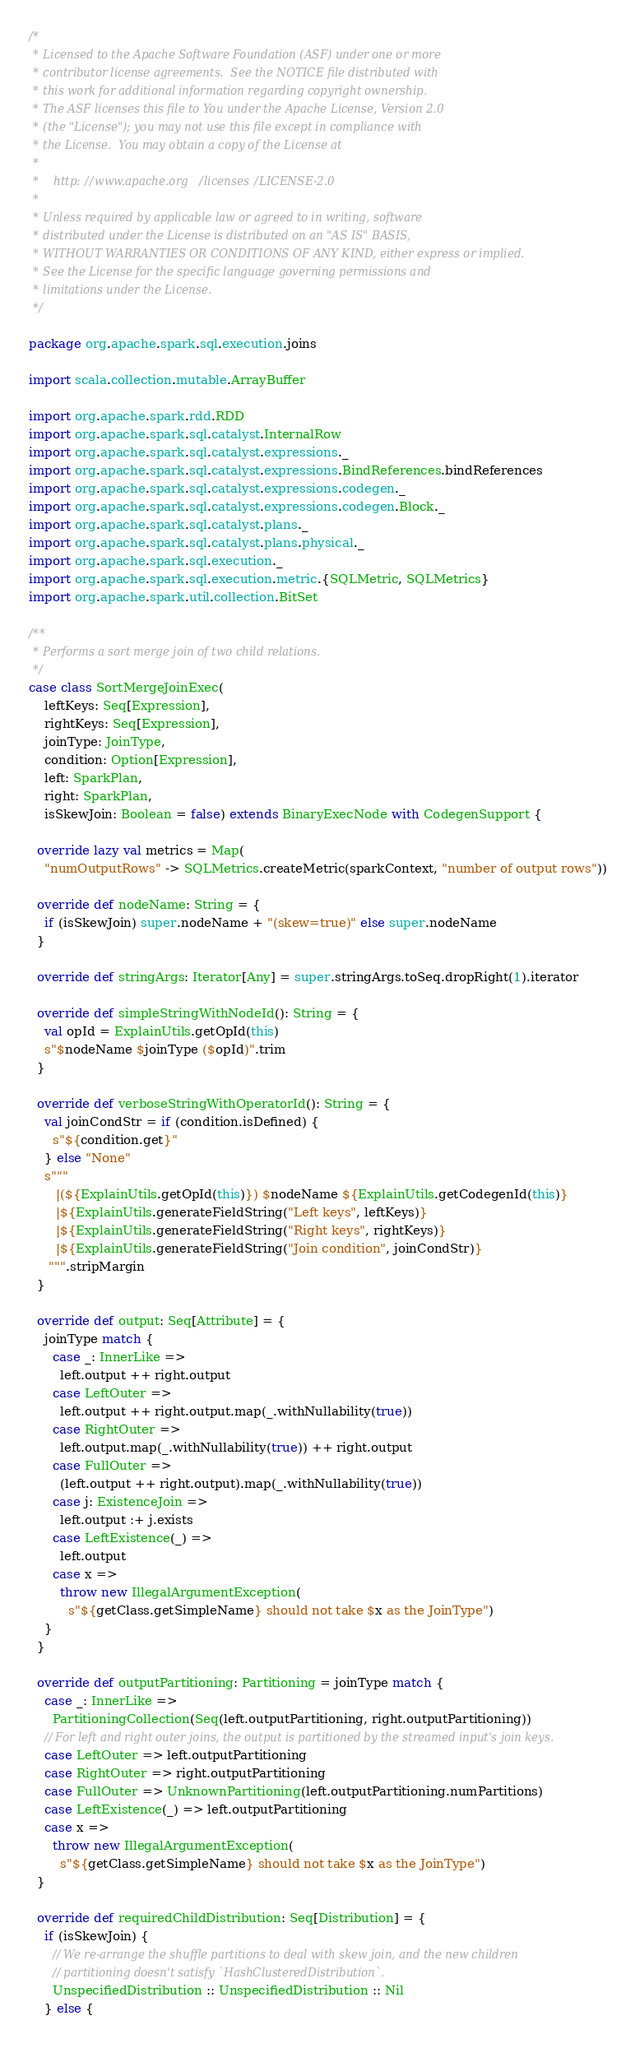<code> <loc_0><loc_0><loc_500><loc_500><_Scala_>/*
 * Licensed to the Apache Software Foundation (ASF) under one or more
 * contributor license agreements.  See the NOTICE file distributed with
 * this work for additional information regarding copyright ownership.
 * The ASF licenses this file to You under the Apache License, Version 2.0
 * (the "License"); you may not use this file except in compliance with
 * the License.  You may obtain a copy of the License at
 *
 *    http://www.apache.org/licenses/LICENSE-2.0
 *
 * Unless required by applicable law or agreed to in writing, software
 * distributed under the License is distributed on an "AS IS" BASIS,
 * WITHOUT WARRANTIES OR CONDITIONS OF ANY KIND, either express or implied.
 * See the License for the specific language governing permissions and
 * limitations under the License.
 */

package org.apache.spark.sql.execution.joins

import scala.collection.mutable.ArrayBuffer

import org.apache.spark.rdd.RDD
import org.apache.spark.sql.catalyst.InternalRow
import org.apache.spark.sql.catalyst.expressions._
import org.apache.spark.sql.catalyst.expressions.BindReferences.bindReferences
import org.apache.spark.sql.catalyst.expressions.codegen._
import org.apache.spark.sql.catalyst.expressions.codegen.Block._
import org.apache.spark.sql.catalyst.plans._
import org.apache.spark.sql.catalyst.plans.physical._
import org.apache.spark.sql.execution._
import org.apache.spark.sql.execution.metric.{SQLMetric, SQLMetrics}
import org.apache.spark.util.collection.BitSet

/**
 * Performs a sort merge join of two child relations.
 */
case class SortMergeJoinExec(
    leftKeys: Seq[Expression],
    rightKeys: Seq[Expression],
    joinType: JoinType,
    condition: Option[Expression],
    left: SparkPlan,
    right: SparkPlan,
    isSkewJoin: Boolean = false) extends BinaryExecNode with CodegenSupport {

  override lazy val metrics = Map(
    "numOutputRows" -> SQLMetrics.createMetric(sparkContext, "number of output rows"))

  override def nodeName: String = {
    if (isSkewJoin) super.nodeName + "(skew=true)" else super.nodeName
  }

  override def stringArgs: Iterator[Any] = super.stringArgs.toSeq.dropRight(1).iterator

  override def simpleStringWithNodeId(): String = {
    val opId = ExplainUtils.getOpId(this)
    s"$nodeName $joinType ($opId)".trim
  }

  override def verboseStringWithOperatorId(): String = {
    val joinCondStr = if (condition.isDefined) {
      s"${condition.get}"
    } else "None"
    s"""
       |(${ExplainUtils.getOpId(this)}) $nodeName ${ExplainUtils.getCodegenId(this)}
       |${ExplainUtils.generateFieldString("Left keys", leftKeys)}
       |${ExplainUtils.generateFieldString("Right keys", rightKeys)}
       |${ExplainUtils.generateFieldString("Join condition", joinCondStr)}
     """.stripMargin
  }

  override def output: Seq[Attribute] = {
    joinType match {
      case _: InnerLike =>
        left.output ++ right.output
      case LeftOuter =>
        left.output ++ right.output.map(_.withNullability(true))
      case RightOuter =>
        left.output.map(_.withNullability(true)) ++ right.output
      case FullOuter =>
        (left.output ++ right.output).map(_.withNullability(true))
      case j: ExistenceJoin =>
        left.output :+ j.exists
      case LeftExistence(_) =>
        left.output
      case x =>
        throw new IllegalArgumentException(
          s"${getClass.getSimpleName} should not take $x as the JoinType")
    }
  }

  override def outputPartitioning: Partitioning = joinType match {
    case _: InnerLike =>
      PartitioningCollection(Seq(left.outputPartitioning, right.outputPartitioning))
    // For left and right outer joins, the output is partitioned by the streamed input's join keys.
    case LeftOuter => left.outputPartitioning
    case RightOuter => right.outputPartitioning
    case FullOuter => UnknownPartitioning(left.outputPartitioning.numPartitions)
    case LeftExistence(_) => left.outputPartitioning
    case x =>
      throw new IllegalArgumentException(
        s"${getClass.getSimpleName} should not take $x as the JoinType")
  }

  override def requiredChildDistribution: Seq[Distribution] = {
    if (isSkewJoin) {
      // We re-arrange the shuffle partitions to deal with skew join, and the new children
      // partitioning doesn't satisfy `HashClusteredDistribution`.
      UnspecifiedDistribution :: UnspecifiedDistribution :: Nil
    } else {</code> 